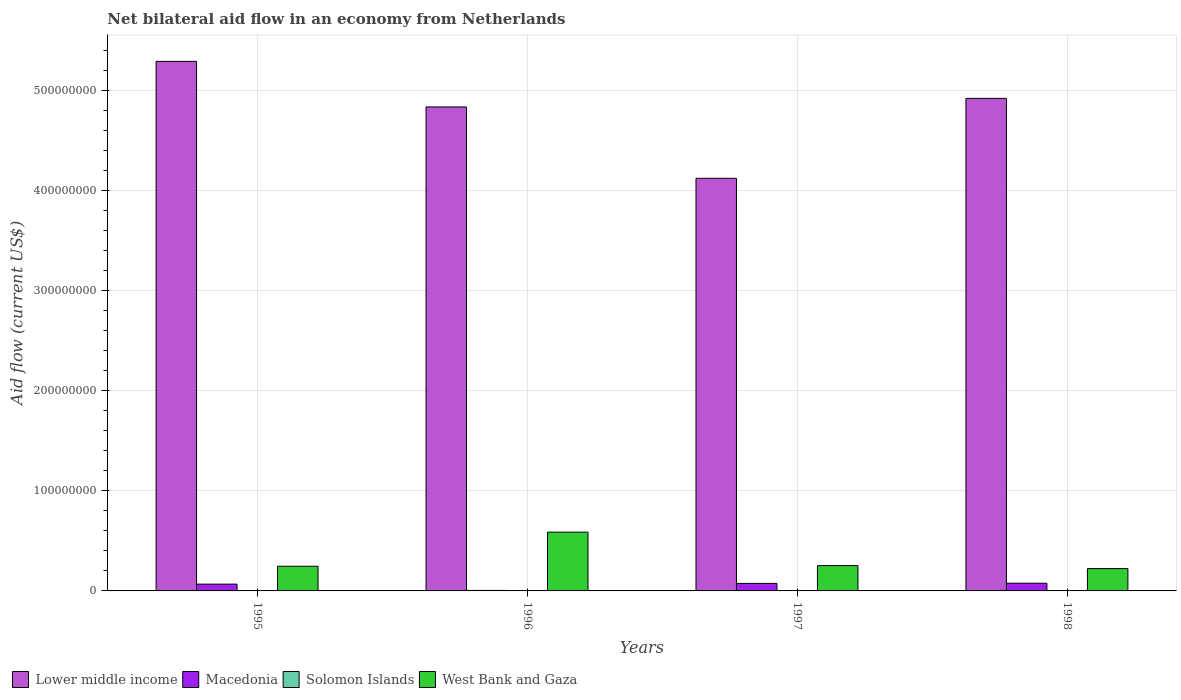Are the number of bars per tick equal to the number of legend labels?
Your response must be concise. Yes. Are the number of bars on each tick of the X-axis equal?
Keep it short and to the point. Yes. How many bars are there on the 4th tick from the right?
Your answer should be compact. 4. What is the label of the 4th group of bars from the left?
Ensure brevity in your answer.  1998. What is the net bilateral aid flow in West Bank and Gaza in 1997?
Your response must be concise. 2.53e+07. Across all years, what is the maximum net bilateral aid flow in West Bank and Gaza?
Keep it short and to the point. 5.88e+07. Across all years, what is the minimum net bilateral aid flow in Lower middle income?
Your response must be concise. 4.12e+08. What is the difference between the net bilateral aid flow in Solomon Islands in 1995 and that in 1998?
Provide a succinct answer. 10000. What is the difference between the net bilateral aid flow in Solomon Islands in 1997 and the net bilateral aid flow in West Bank and Gaza in 1998?
Your response must be concise. -2.21e+07. What is the average net bilateral aid flow in Lower middle income per year?
Provide a succinct answer. 4.80e+08. In the year 1997, what is the difference between the net bilateral aid flow in Solomon Islands and net bilateral aid flow in Macedonia?
Your answer should be compact. -7.32e+06. In how many years, is the net bilateral aid flow in West Bank and Gaza greater than 440000000 US$?
Give a very brief answer. 0. What is the ratio of the net bilateral aid flow in Solomon Islands in 1996 to that in 1998?
Your answer should be very brief. 0.08. What is the difference between the highest and the second highest net bilateral aid flow in West Bank and Gaza?
Give a very brief answer. 3.35e+07. What is the difference between the highest and the lowest net bilateral aid flow in Lower middle income?
Ensure brevity in your answer.  1.17e+08. Is the sum of the net bilateral aid flow in Solomon Islands in 1996 and 1998 greater than the maximum net bilateral aid flow in Lower middle income across all years?
Keep it short and to the point. No. Is it the case that in every year, the sum of the net bilateral aid flow in West Bank and Gaza and net bilateral aid flow in Lower middle income is greater than the sum of net bilateral aid flow in Solomon Islands and net bilateral aid flow in Macedonia?
Give a very brief answer. Yes. What does the 4th bar from the left in 1996 represents?
Offer a terse response. West Bank and Gaza. What does the 3rd bar from the right in 1995 represents?
Your response must be concise. Macedonia. Is it the case that in every year, the sum of the net bilateral aid flow in Macedonia and net bilateral aid flow in Solomon Islands is greater than the net bilateral aid flow in West Bank and Gaza?
Offer a very short reply. No. How many bars are there?
Your answer should be very brief. 16. Are all the bars in the graph horizontal?
Your answer should be compact. No. How many years are there in the graph?
Make the answer very short. 4. What is the difference between two consecutive major ticks on the Y-axis?
Your answer should be compact. 1.00e+08. Does the graph contain grids?
Offer a very short reply. Yes. Where does the legend appear in the graph?
Your response must be concise. Bottom left. How many legend labels are there?
Your response must be concise. 4. What is the title of the graph?
Provide a short and direct response. Net bilateral aid flow in an economy from Netherlands. Does "Liberia" appear as one of the legend labels in the graph?
Make the answer very short. No. What is the label or title of the Y-axis?
Offer a terse response. Aid flow (current US$). What is the Aid flow (current US$) in Lower middle income in 1995?
Your response must be concise. 5.29e+08. What is the Aid flow (current US$) in Macedonia in 1995?
Ensure brevity in your answer.  6.79e+06. What is the Aid flow (current US$) in West Bank and Gaza in 1995?
Ensure brevity in your answer.  2.47e+07. What is the Aid flow (current US$) in Lower middle income in 1996?
Give a very brief answer. 4.84e+08. What is the Aid flow (current US$) in Macedonia in 1996?
Make the answer very short. 5.10e+05. What is the Aid flow (current US$) of Solomon Islands in 1996?
Your response must be concise. 10000. What is the Aid flow (current US$) in West Bank and Gaza in 1996?
Your answer should be compact. 5.88e+07. What is the Aid flow (current US$) in Lower middle income in 1997?
Your answer should be very brief. 4.12e+08. What is the Aid flow (current US$) in Macedonia in 1997?
Your answer should be compact. 7.52e+06. What is the Aid flow (current US$) of Solomon Islands in 1997?
Offer a very short reply. 2.00e+05. What is the Aid flow (current US$) of West Bank and Gaza in 1997?
Your response must be concise. 2.53e+07. What is the Aid flow (current US$) in Lower middle income in 1998?
Provide a succinct answer. 4.92e+08. What is the Aid flow (current US$) in Macedonia in 1998?
Offer a very short reply. 7.69e+06. What is the Aid flow (current US$) of West Bank and Gaza in 1998?
Ensure brevity in your answer.  2.23e+07. Across all years, what is the maximum Aid flow (current US$) in Lower middle income?
Your answer should be very brief. 5.29e+08. Across all years, what is the maximum Aid flow (current US$) in Macedonia?
Ensure brevity in your answer.  7.69e+06. Across all years, what is the maximum Aid flow (current US$) in West Bank and Gaza?
Give a very brief answer. 5.88e+07. Across all years, what is the minimum Aid flow (current US$) of Lower middle income?
Keep it short and to the point. 4.12e+08. Across all years, what is the minimum Aid flow (current US$) of Macedonia?
Keep it short and to the point. 5.10e+05. Across all years, what is the minimum Aid flow (current US$) in West Bank and Gaza?
Provide a succinct answer. 2.23e+07. What is the total Aid flow (current US$) of Lower middle income in the graph?
Offer a very short reply. 1.92e+09. What is the total Aid flow (current US$) of Macedonia in the graph?
Your answer should be compact. 2.25e+07. What is the total Aid flow (current US$) of Solomon Islands in the graph?
Make the answer very short. 4.80e+05. What is the total Aid flow (current US$) in West Bank and Gaza in the graph?
Give a very brief answer. 1.31e+08. What is the difference between the Aid flow (current US$) of Lower middle income in 1995 and that in 1996?
Offer a very short reply. 4.56e+07. What is the difference between the Aid flow (current US$) in Macedonia in 1995 and that in 1996?
Offer a very short reply. 6.28e+06. What is the difference between the Aid flow (current US$) in West Bank and Gaza in 1995 and that in 1996?
Ensure brevity in your answer.  -3.41e+07. What is the difference between the Aid flow (current US$) in Lower middle income in 1995 and that in 1997?
Your response must be concise. 1.17e+08. What is the difference between the Aid flow (current US$) of Macedonia in 1995 and that in 1997?
Give a very brief answer. -7.30e+05. What is the difference between the Aid flow (current US$) of Solomon Islands in 1995 and that in 1997?
Your response must be concise. -6.00e+04. What is the difference between the Aid flow (current US$) of West Bank and Gaza in 1995 and that in 1997?
Make the answer very short. -5.90e+05. What is the difference between the Aid flow (current US$) of Lower middle income in 1995 and that in 1998?
Your response must be concise. 3.70e+07. What is the difference between the Aid flow (current US$) in Macedonia in 1995 and that in 1998?
Make the answer very short. -9.00e+05. What is the difference between the Aid flow (current US$) in Solomon Islands in 1995 and that in 1998?
Your answer should be compact. 10000. What is the difference between the Aid flow (current US$) in West Bank and Gaza in 1995 and that in 1998?
Offer a terse response. 2.36e+06. What is the difference between the Aid flow (current US$) in Lower middle income in 1996 and that in 1997?
Offer a terse response. 7.14e+07. What is the difference between the Aid flow (current US$) of Macedonia in 1996 and that in 1997?
Ensure brevity in your answer.  -7.01e+06. What is the difference between the Aid flow (current US$) in Solomon Islands in 1996 and that in 1997?
Your answer should be compact. -1.90e+05. What is the difference between the Aid flow (current US$) in West Bank and Gaza in 1996 and that in 1997?
Offer a very short reply. 3.35e+07. What is the difference between the Aid flow (current US$) in Lower middle income in 1996 and that in 1998?
Your answer should be very brief. -8.56e+06. What is the difference between the Aid flow (current US$) of Macedonia in 1996 and that in 1998?
Give a very brief answer. -7.18e+06. What is the difference between the Aid flow (current US$) in West Bank and Gaza in 1996 and that in 1998?
Offer a very short reply. 3.64e+07. What is the difference between the Aid flow (current US$) in Lower middle income in 1997 and that in 1998?
Keep it short and to the point. -7.99e+07. What is the difference between the Aid flow (current US$) of Macedonia in 1997 and that in 1998?
Offer a terse response. -1.70e+05. What is the difference between the Aid flow (current US$) in Solomon Islands in 1997 and that in 1998?
Give a very brief answer. 7.00e+04. What is the difference between the Aid flow (current US$) of West Bank and Gaza in 1997 and that in 1998?
Ensure brevity in your answer.  2.95e+06. What is the difference between the Aid flow (current US$) in Lower middle income in 1995 and the Aid flow (current US$) in Macedonia in 1996?
Your response must be concise. 5.29e+08. What is the difference between the Aid flow (current US$) in Lower middle income in 1995 and the Aid flow (current US$) in Solomon Islands in 1996?
Give a very brief answer. 5.29e+08. What is the difference between the Aid flow (current US$) of Lower middle income in 1995 and the Aid flow (current US$) of West Bank and Gaza in 1996?
Offer a very short reply. 4.71e+08. What is the difference between the Aid flow (current US$) in Macedonia in 1995 and the Aid flow (current US$) in Solomon Islands in 1996?
Provide a short and direct response. 6.78e+06. What is the difference between the Aid flow (current US$) of Macedonia in 1995 and the Aid flow (current US$) of West Bank and Gaza in 1996?
Your response must be concise. -5.20e+07. What is the difference between the Aid flow (current US$) of Solomon Islands in 1995 and the Aid flow (current US$) of West Bank and Gaza in 1996?
Provide a succinct answer. -5.86e+07. What is the difference between the Aid flow (current US$) of Lower middle income in 1995 and the Aid flow (current US$) of Macedonia in 1997?
Make the answer very short. 5.22e+08. What is the difference between the Aid flow (current US$) of Lower middle income in 1995 and the Aid flow (current US$) of Solomon Islands in 1997?
Your answer should be very brief. 5.29e+08. What is the difference between the Aid flow (current US$) in Lower middle income in 1995 and the Aid flow (current US$) in West Bank and Gaza in 1997?
Ensure brevity in your answer.  5.04e+08. What is the difference between the Aid flow (current US$) in Macedonia in 1995 and the Aid flow (current US$) in Solomon Islands in 1997?
Your answer should be very brief. 6.59e+06. What is the difference between the Aid flow (current US$) of Macedonia in 1995 and the Aid flow (current US$) of West Bank and Gaza in 1997?
Keep it short and to the point. -1.85e+07. What is the difference between the Aid flow (current US$) in Solomon Islands in 1995 and the Aid flow (current US$) in West Bank and Gaza in 1997?
Give a very brief answer. -2.51e+07. What is the difference between the Aid flow (current US$) in Lower middle income in 1995 and the Aid flow (current US$) in Macedonia in 1998?
Give a very brief answer. 5.22e+08. What is the difference between the Aid flow (current US$) of Lower middle income in 1995 and the Aid flow (current US$) of Solomon Islands in 1998?
Offer a terse response. 5.29e+08. What is the difference between the Aid flow (current US$) in Lower middle income in 1995 and the Aid flow (current US$) in West Bank and Gaza in 1998?
Your answer should be compact. 5.07e+08. What is the difference between the Aid flow (current US$) in Macedonia in 1995 and the Aid flow (current US$) in Solomon Islands in 1998?
Your answer should be very brief. 6.66e+06. What is the difference between the Aid flow (current US$) of Macedonia in 1995 and the Aid flow (current US$) of West Bank and Gaza in 1998?
Make the answer very short. -1.55e+07. What is the difference between the Aid flow (current US$) in Solomon Islands in 1995 and the Aid flow (current US$) in West Bank and Gaza in 1998?
Give a very brief answer. -2.22e+07. What is the difference between the Aid flow (current US$) of Lower middle income in 1996 and the Aid flow (current US$) of Macedonia in 1997?
Offer a terse response. 4.76e+08. What is the difference between the Aid flow (current US$) in Lower middle income in 1996 and the Aid flow (current US$) in Solomon Islands in 1997?
Provide a short and direct response. 4.84e+08. What is the difference between the Aid flow (current US$) of Lower middle income in 1996 and the Aid flow (current US$) of West Bank and Gaza in 1997?
Make the answer very short. 4.59e+08. What is the difference between the Aid flow (current US$) of Macedonia in 1996 and the Aid flow (current US$) of West Bank and Gaza in 1997?
Ensure brevity in your answer.  -2.48e+07. What is the difference between the Aid flow (current US$) in Solomon Islands in 1996 and the Aid flow (current US$) in West Bank and Gaza in 1997?
Your answer should be very brief. -2.53e+07. What is the difference between the Aid flow (current US$) in Lower middle income in 1996 and the Aid flow (current US$) in Macedonia in 1998?
Your response must be concise. 4.76e+08. What is the difference between the Aid flow (current US$) in Lower middle income in 1996 and the Aid flow (current US$) in Solomon Islands in 1998?
Make the answer very short. 4.84e+08. What is the difference between the Aid flow (current US$) in Lower middle income in 1996 and the Aid flow (current US$) in West Bank and Gaza in 1998?
Give a very brief answer. 4.62e+08. What is the difference between the Aid flow (current US$) of Macedonia in 1996 and the Aid flow (current US$) of Solomon Islands in 1998?
Provide a succinct answer. 3.80e+05. What is the difference between the Aid flow (current US$) of Macedonia in 1996 and the Aid flow (current US$) of West Bank and Gaza in 1998?
Give a very brief answer. -2.18e+07. What is the difference between the Aid flow (current US$) in Solomon Islands in 1996 and the Aid flow (current US$) in West Bank and Gaza in 1998?
Provide a short and direct response. -2.23e+07. What is the difference between the Aid flow (current US$) of Lower middle income in 1997 and the Aid flow (current US$) of Macedonia in 1998?
Provide a short and direct response. 4.05e+08. What is the difference between the Aid flow (current US$) of Lower middle income in 1997 and the Aid flow (current US$) of Solomon Islands in 1998?
Provide a succinct answer. 4.12e+08. What is the difference between the Aid flow (current US$) in Lower middle income in 1997 and the Aid flow (current US$) in West Bank and Gaza in 1998?
Offer a very short reply. 3.90e+08. What is the difference between the Aid flow (current US$) in Macedonia in 1997 and the Aid flow (current US$) in Solomon Islands in 1998?
Provide a succinct answer. 7.39e+06. What is the difference between the Aid flow (current US$) in Macedonia in 1997 and the Aid flow (current US$) in West Bank and Gaza in 1998?
Your answer should be compact. -1.48e+07. What is the difference between the Aid flow (current US$) in Solomon Islands in 1997 and the Aid flow (current US$) in West Bank and Gaza in 1998?
Provide a short and direct response. -2.21e+07. What is the average Aid flow (current US$) of Lower middle income per year?
Provide a succinct answer. 4.80e+08. What is the average Aid flow (current US$) of Macedonia per year?
Your response must be concise. 5.63e+06. What is the average Aid flow (current US$) in West Bank and Gaza per year?
Ensure brevity in your answer.  3.28e+07. In the year 1995, what is the difference between the Aid flow (current US$) of Lower middle income and Aid flow (current US$) of Macedonia?
Your response must be concise. 5.23e+08. In the year 1995, what is the difference between the Aid flow (current US$) of Lower middle income and Aid flow (current US$) of Solomon Islands?
Provide a short and direct response. 5.29e+08. In the year 1995, what is the difference between the Aid flow (current US$) in Lower middle income and Aid flow (current US$) in West Bank and Gaza?
Offer a very short reply. 5.05e+08. In the year 1995, what is the difference between the Aid flow (current US$) in Macedonia and Aid flow (current US$) in Solomon Islands?
Provide a short and direct response. 6.65e+06. In the year 1995, what is the difference between the Aid flow (current US$) in Macedonia and Aid flow (current US$) in West Bank and Gaza?
Offer a very short reply. -1.79e+07. In the year 1995, what is the difference between the Aid flow (current US$) in Solomon Islands and Aid flow (current US$) in West Bank and Gaza?
Ensure brevity in your answer.  -2.46e+07. In the year 1996, what is the difference between the Aid flow (current US$) in Lower middle income and Aid flow (current US$) in Macedonia?
Give a very brief answer. 4.83e+08. In the year 1996, what is the difference between the Aid flow (current US$) of Lower middle income and Aid flow (current US$) of Solomon Islands?
Ensure brevity in your answer.  4.84e+08. In the year 1996, what is the difference between the Aid flow (current US$) in Lower middle income and Aid flow (current US$) in West Bank and Gaza?
Your answer should be very brief. 4.25e+08. In the year 1996, what is the difference between the Aid flow (current US$) in Macedonia and Aid flow (current US$) in Solomon Islands?
Offer a terse response. 5.00e+05. In the year 1996, what is the difference between the Aid flow (current US$) of Macedonia and Aid flow (current US$) of West Bank and Gaza?
Your response must be concise. -5.82e+07. In the year 1996, what is the difference between the Aid flow (current US$) in Solomon Islands and Aid flow (current US$) in West Bank and Gaza?
Keep it short and to the point. -5.87e+07. In the year 1997, what is the difference between the Aid flow (current US$) in Lower middle income and Aid flow (current US$) in Macedonia?
Offer a terse response. 4.05e+08. In the year 1997, what is the difference between the Aid flow (current US$) in Lower middle income and Aid flow (current US$) in Solomon Islands?
Keep it short and to the point. 4.12e+08. In the year 1997, what is the difference between the Aid flow (current US$) of Lower middle income and Aid flow (current US$) of West Bank and Gaza?
Your answer should be very brief. 3.87e+08. In the year 1997, what is the difference between the Aid flow (current US$) of Macedonia and Aid flow (current US$) of Solomon Islands?
Ensure brevity in your answer.  7.32e+06. In the year 1997, what is the difference between the Aid flow (current US$) in Macedonia and Aid flow (current US$) in West Bank and Gaza?
Provide a succinct answer. -1.78e+07. In the year 1997, what is the difference between the Aid flow (current US$) of Solomon Islands and Aid flow (current US$) of West Bank and Gaza?
Provide a succinct answer. -2.51e+07. In the year 1998, what is the difference between the Aid flow (current US$) of Lower middle income and Aid flow (current US$) of Macedonia?
Give a very brief answer. 4.85e+08. In the year 1998, what is the difference between the Aid flow (current US$) in Lower middle income and Aid flow (current US$) in Solomon Islands?
Your answer should be very brief. 4.92e+08. In the year 1998, what is the difference between the Aid flow (current US$) of Lower middle income and Aid flow (current US$) of West Bank and Gaza?
Give a very brief answer. 4.70e+08. In the year 1998, what is the difference between the Aid flow (current US$) in Macedonia and Aid flow (current US$) in Solomon Islands?
Offer a very short reply. 7.56e+06. In the year 1998, what is the difference between the Aid flow (current US$) in Macedonia and Aid flow (current US$) in West Bank and Gaza?
Give a very brief answer. -1.46e+07. In the year 1998, what is the difference between the Aid flow (current US$) in Solomon Islands and Aid flow (current US$) in West Bank and Gaza?
Keep it short and to the point. -2.22e+07. What is the ratio of the Aid flow (current US$) in Lower middle income in 1995 to that in 1996?
Offer a terse response. 1.09. What is the ratio of the Aid flow (current US$) in Macedonia in 1995 to that in 1996?
Your answer should be compact. 13.31. What is the ratio of the Aid flow (current US$) of Solomon Islands in 1995 to that in 1996?
Provide a short and direct response. 14. What is the ratio of the Aid flow (current US$) of West Bank and Gaza in 1995 to that in 1996?
Provide a short and direct response. 0.42. What is the ratio of the Aid flow (current US$) in Lower middle income in 1995 to that in 1997?
Provide a short and direct response. 1.28. What is the ratio of the Aid flow (current US$) in Macedonia in 1995 to that in 1997?
Your answer should be compact. 0.9. What is the ratio of the Aid flow (current US$) in West Bank and Gaza in 1995 to that in 1997?
Your answer should be compact. 0.98. What is the ratio of the Aid flow (current US$) in Lower middle income in 1995 to that in 1998?
Keep it short and to the point. 1.08. What is the ratio of the Aid flow (current US$) of Macedonia in 1995 to that in 1998?
Your response must be concise. 0.88. What is the ratio of the Aid flow (current US$) in Solomon Islands in 1995 to that in 1998?
Provide a succinct answer. 1.08. What is the ratio of the Aid flow (current US$) of West Bank and Gaza in 1995 to that in 1998?
Provide a succinct answer. 1.11. What is the ratio of the Aid flow (current US$) of Lower middle income in 1996 to that in 1997?
Offer a terse response. 1.17. What is the ratio of the Aid flow (current US$) of Macedonia in 1996 to that in 1997?
Your answer should be compact. 0.07. What is the ratio of the Aid flow (current US$) of West Bank and Gaza in 1996 to that in 1997?
Your response must be concise. 2.32. What is the ratio of the Aid flow (current US$) in Lower middle income in 1996 to that in 1998?
Your response must be concise. 0.98. What is the ratio of the Aid flow (current US$) of Macedonia in 1996 to that in 1998?
Offer a very short reply. 0.07. What is the ratio of the Aid flow (current US$) in Solomon Islands in 1996 to that in 1998?
Your response must be concise. 0.08. What is the ratio of the Aid flow (current US$) of West Bank and Gaza in 1996 to that in 1998?
Ensure brevity in your answer.  2.63. What is the ratio of the Aid flow (current US$) of Lower middle income in 1997 to that in 1998?
Your answer should be compact. 0.84. What is the ratio of the Aid flow (current US$) of Macedonia in 1997 to that in 1998?
Your answer should be compact. 0.98. What is the ratio of the Aid flow (current US$) in Solomon Islands in 1997 to that in 1998?
Offer a terse response. 1.54. What is the ratio of the Aid flow (current US$) in West Bank and Gaza in 1997 to that in 1998?
Provide a short and direct response. 1.13. What is the difference between the highest and the second highest Aid flow (current US$) in Lower middle income?
Ensure brevity in your answer.  3.70e+07. What is the difference between the highest and the second highest Aid flow (current US$) in Macedonia?
Offer a terse response. 1.70e+05. What is the difference between the highest and the second highest Aid flow (current US$) in Solomon Islands?
Provide a succinct answer. 6.00e+04. What is the difference between the highest and the second highest Aid flow (current US$) of West Bank and Gaza?
Provide a succinct answer. 3.35e+07. What is the difference between the highest and the lowest Aid flow (current US$) in Lower middle income?
Provide a succinct answer. 1.17e+08. What is the difference between the highest and the lowest Aid flow (current US$) of Macedonia?
Your response must be concise. 7.18e+06. What is the difference between the highest and the lowest Aid flow (current US$) of West Bank and Gaza?
Your answer should be compact. 3.64e+07. 